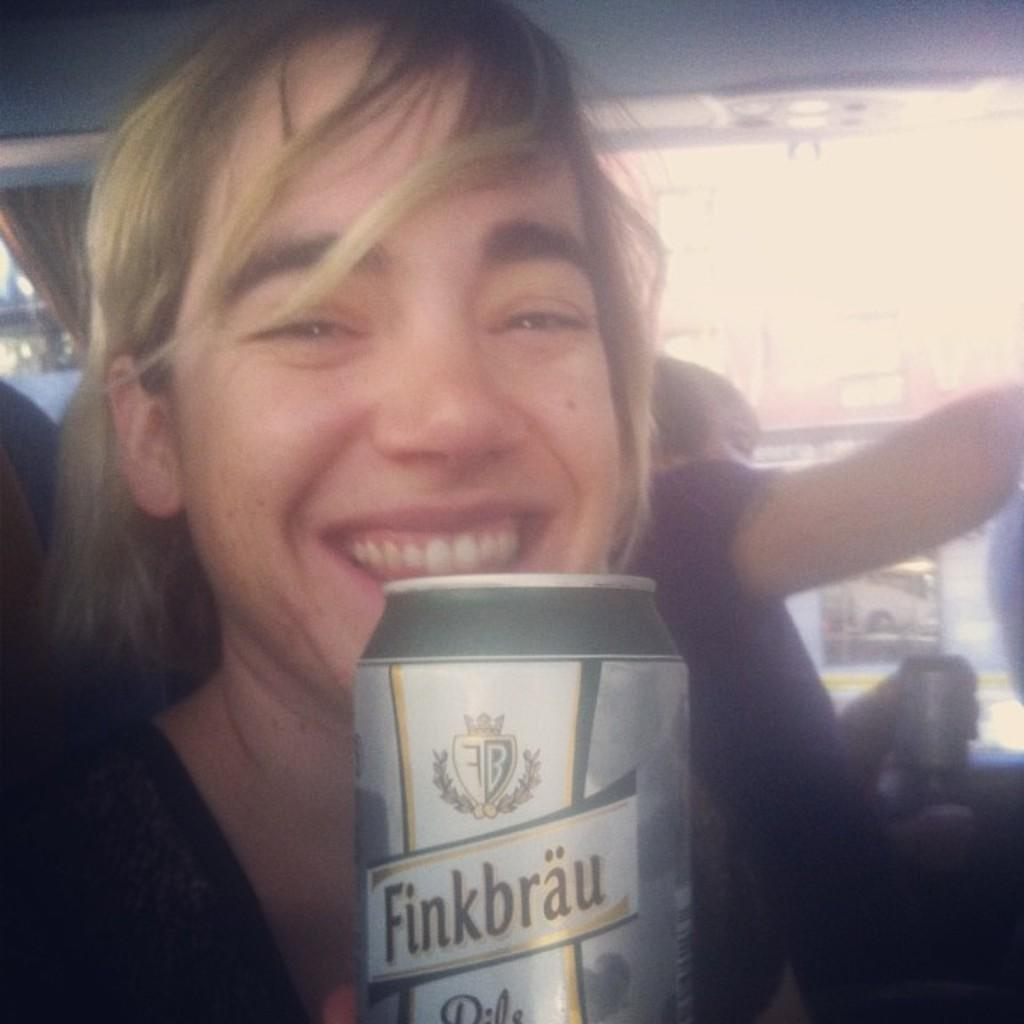What is the main subject of the image? There is a person in the image. What is the person doing in the image? The person is smiling. What object is the person holding in the image? The person is holding a tin. Can you describe the other person in the image? There is another person sitting in the background of the image. What type of fish is the person teaching in the image? There is no fish or teaching activity present in the image. What knowledge is the person sharing with the other person in the image? There is no indication of knowledge sharing or any specific subject being discussed in the image. 